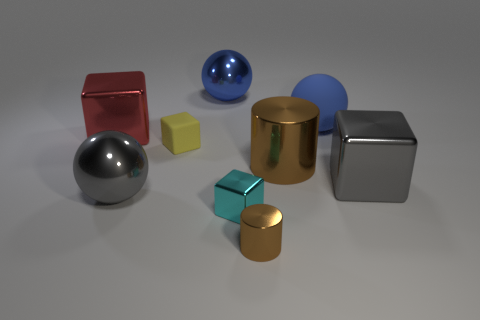There is a large cube behind the small yellow matte thing; what is its material?
Give a very brief answer. Metal. How many big brown things have the same shape as the big red metallic thing?
Offer a terse response. 0. Does the small shiny cylinder have the same color as the big shiny cylinder?
Provide a succinct answer. Yes. What is the material of the small cube behind the brown metal thing on the right side of the tiny brown shiny object in front of the tiny cyan object?
Your answer should be compact. Rubber. Are there any big things on the left side of the gray shiny block?
Make the answer very short. Yes. There is another blue object that is the same size as the blue shiny object; what shape is it?
Give a very brief answer. Sphere. Do the cyan cube and the large red object have the same material?
Give a very brief answer. Yes. What number of rubber objects are large gray objects or large red things?
Your answer should be compact. 0. There is a metal thing that is the same color as the large rubber ball; what shape is it?
Your response must be concise. Sphere. Does the tiny thing that is in front of the tiny cyan block have the same color as the large metallic cylinder?
Your response must be concise. Yes. 